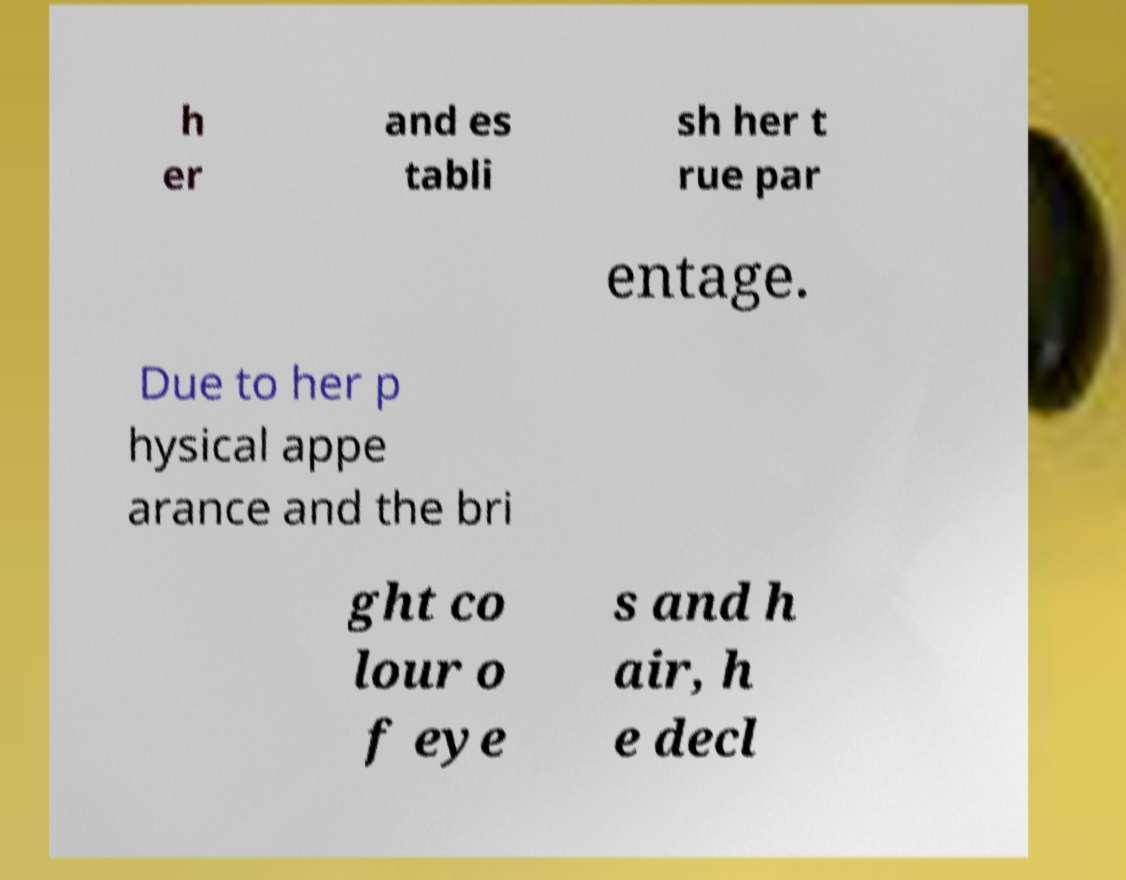I need the written content from this picture converted into text. Can you do that? h er and es tabli sh her t rue par entage. Due to her p hysical appe arance and the bri ght co lour o f eye s and h air, h e decl 